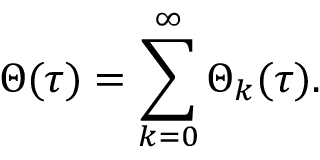Convert formula to latex. <formula><loc_0><loc_0><loc_500><loc_500>\Theta ( \tau ) = \sum _ { k = 0 } ^ { \infty } \Theta _ { k } ( \tau ) .</formula> 